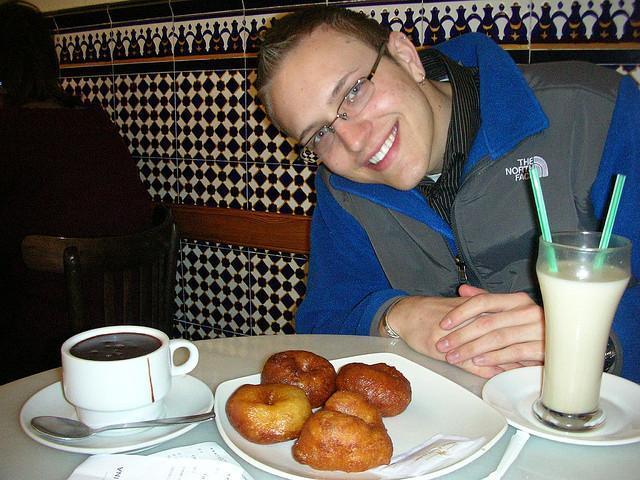How many straws are in the picture?
Give a very brief answer. 2. How many cups are in the photo?
Give a very brief answer. 2. How many people are visible?
Give a very brief answer. 2. How many donuts are there?
Give a very brief answer. 4. 